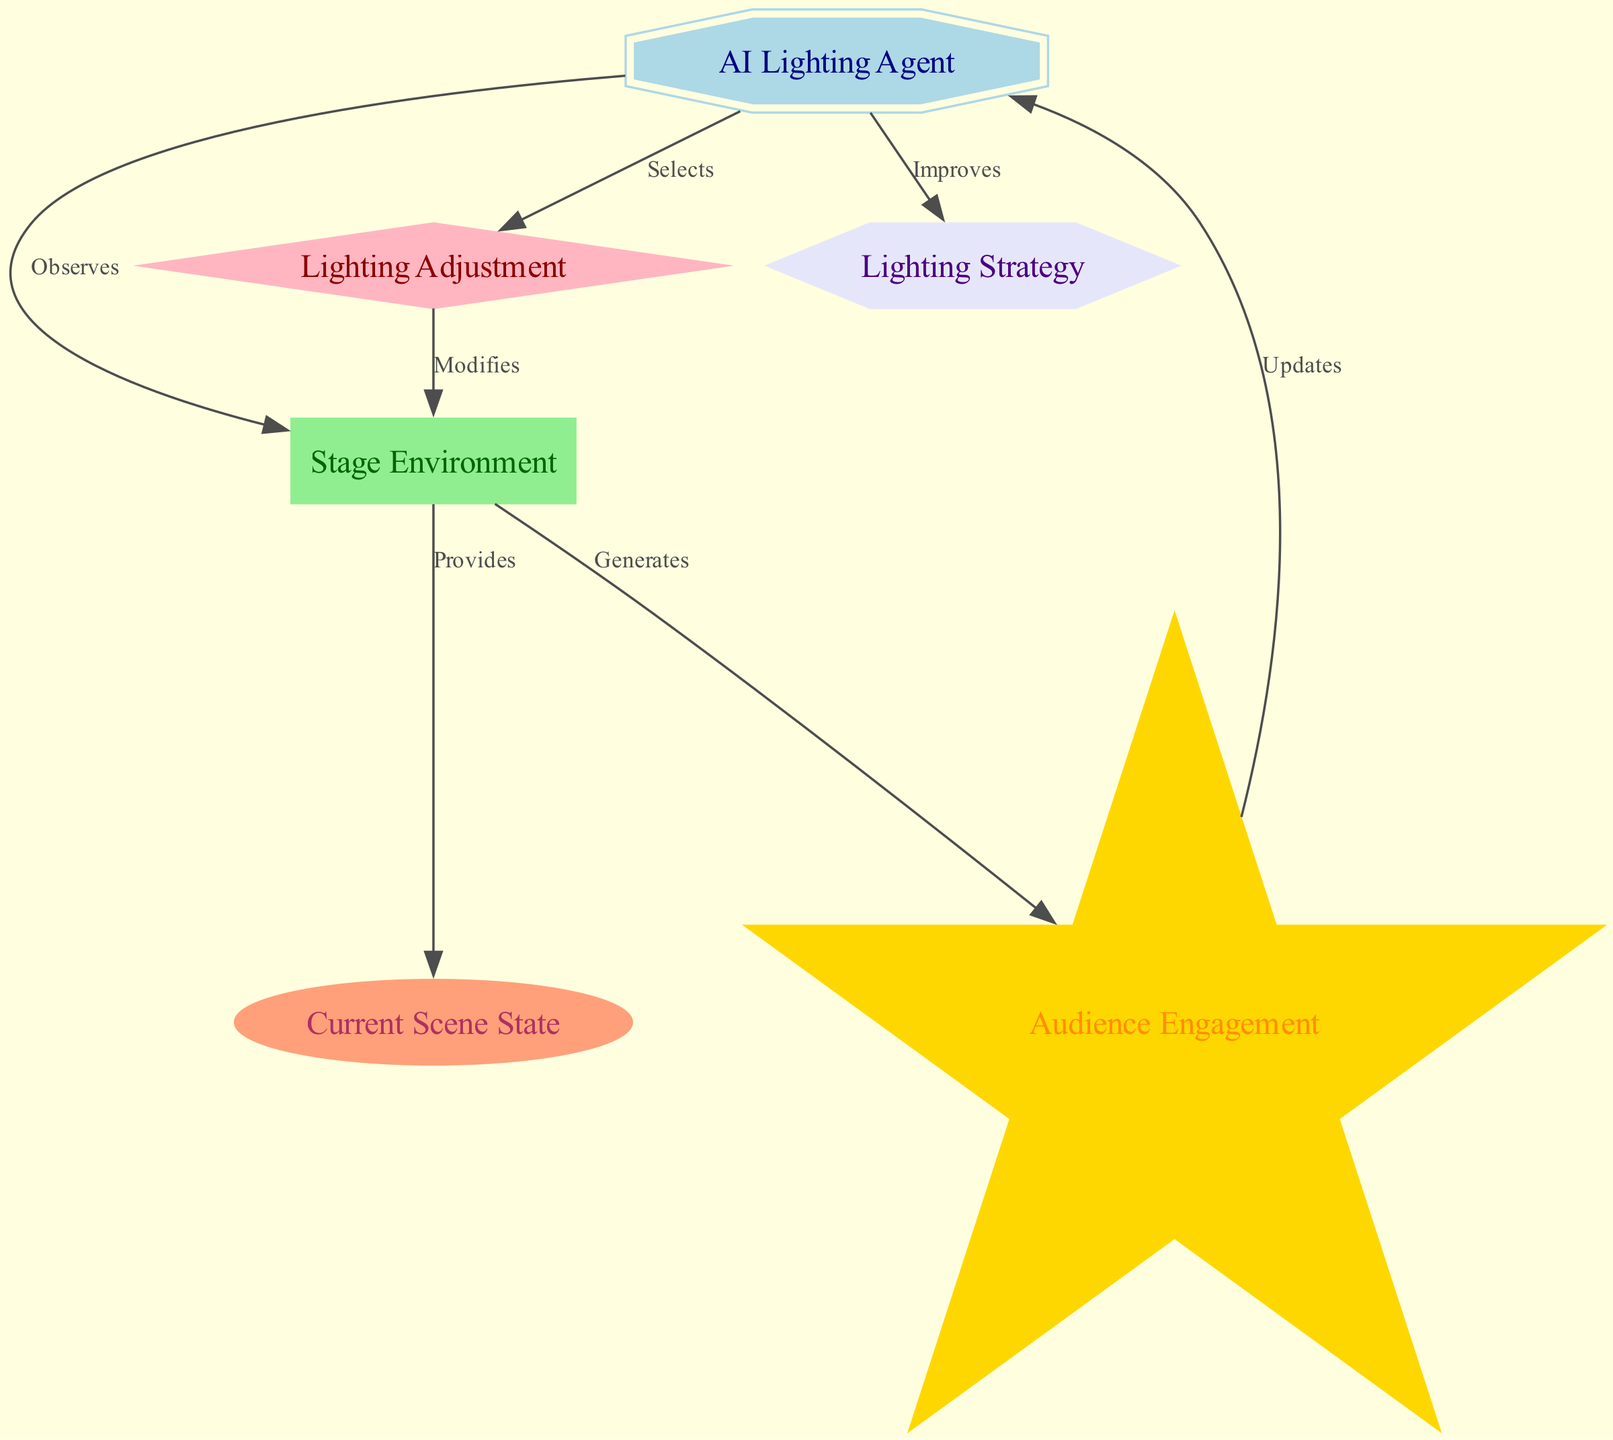What is the role of the AI agent in the diagram? The AI Lighting Agent observes the stage environment and selects lighting adjustments based on the current scene state.
Answer: AI Lighting Agent How many nodes are present in the diagram? By counting the nodes listed, we find there are six nodes: AI Lighting Agent, Stage Environment, Current Scene State, Lighting Adjustment, Audience Engagement, and Lighting Strategy.
Answer: 6 What does the agent update after receiving a reward? The agent updates its policy, which is the lighting strategy used to select actions in future scenes.
Answer: Policy Which node provides the current scene state? The Stage Environment node provides the current scene state to the AI Lighting Agent.
Answer: Stage Environment What is the shape of the reward node? The reward node is represented as a star shape in the diagram.
Answer: Star How does the environment generate a reward? The environment generates a reward after receiving modifications from the action node (lighting adjustments) by evaluating audience engagement.
Answer: Generates What happens after the agent selects an action? After selecting an action (lighting adjustment), it modifies the environment, which leads to an updated current scene state and audience engagement.
Answer: Modifies What kind of edge connects the reward to the agent? The edge connecting the reward to the agent is labeled "Updates," indicating a flow of information that alters the agent's strategy.
Answer: Updates Which node receives information from the current scene state? The AI Lighting Agent receives information from the current scene state provided by the stage environment.
Answer: AI Lighting Agent 